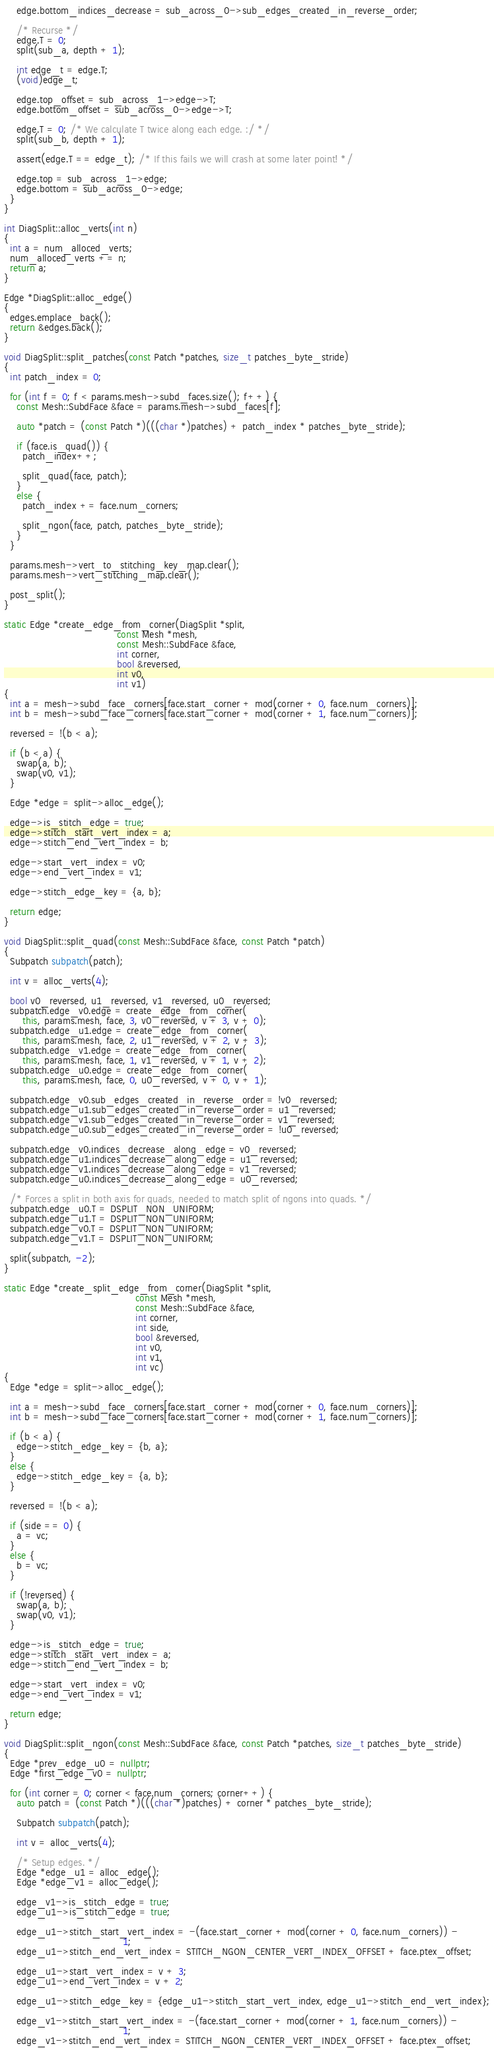Convert code to text. <code><loc_0><loc_0><loc_500><loc_500><_C++_>    edge.bottom_indices_decrease = sub_across_0->sub_edges_created_in_reverse_order;

    /* Recurse */
    edge.T = 0;
    split(sub_a, depth + 1);

    int edge_t = edge.T;
    (void)edge_t;

    edge.top_offset = sub_across_1->edge->T;
    edge.bottom_offset = sub_across_0->edge->T;

    edge.T = 0; /* We calculate T twice along each edge. :/ */
    split(sub_b, depth + 1);

    assert(edge.T == edge_t); /* If this fails we will crash at some later point! */

    edge.top = sub_across_1->edge;
    edge.bottom = sub_across_0->edge;
  }
}

int DiagSplit::alloc_verts(int n)
{
  int a = num_alloced_verts;
  num_alloced_verts += n;
  return a;
}

Edge *DiagSplit::alloc_edge()
{
  edges.emplace_back();
  return &edges.back();
}

void DiagSplit::split_patches(const Patch *patches, size_t patches_byte_stride)
{
  int patch_index = 0;

  for (int f = 0; f < params.mesh->subd_faces.size(); f++) {
    const Mesh::SubdFace &face = params.mesh->subd_faces[f];

    auto *patch = (const Patch *)(((char *)patches) + patch_index * patches_byte_stride);

    if (face.is_quad()) {
      patch_index++;

      split_quad(face, patch);
    }
    else {
      patch_index += face.num_corners;

      split_ngon(face, patch, patches_byte_stride);
    }
  }

  params.mesh->vert_to_stitching_key_map.clear();
  params.mesh->vert_stitching_map.clear();

  post_split();
}

static Edge *create_edge_from_corner(DiagSplit *split,
                                     const Mesh *mesh,
                                     const Mesh::SubdFace &face,
                                     int corner,
                                     bool &reversed,
                                     int v0,
                                     int v1)
{
  int a = mesh->subd_face_corners[face.start_corner + mod(corner + 0, face.num_corners)];
  int b = mesh->subd_face_corners[face.start_corner + mod(corner + 1, face.num_corners)];

  reversed = !(b < a);

  if (b < a) {
    swap(a, b);
    swap(v0, v1);
  }

  Edge *edge = split->alloc_edge();

  edge->is_stitch_edge = true;
  edge->stitch_start_vert_index = a;
  edge->stitch_end_vert_index = b;

  edge->start_vert_index = v0;
  edge->end_vert_index = v1;

  edge->stitch_edge_key = {a, b};

  return edge;
}

void DiagSplit::split_quad(const Mesh::SubdFace &face, const Patch *patch)
{
  Subpatch subpatch(patch);

  int v = alloc_verts(4);

  bool v0_reversed, u1_reversed, v1_reversed, u0_reversed;
  subpatch.edge_v0.edge = create_edge_from_corner(
      this, params.mesh, face, 3, v0_reversed, v + 3, v + 0);
  subpatch.edge_u1.edge = create_edge_from_corner(
      this, params.mesh, face, 2, u1_reversed, v + 2, v + 3);
  subpatch.edge_v1.edge = create_edge_from_corner(
      this, params.mesh, face, 1, v1_reversed, v + 1, v + 2);
  subpatch.edge_u0.edge = create_edge_from_corner(
      this, params.mesh, face, 0, u0_reversed, v + 0, v + 1);

  subpatch.edge_v0.sub_edges_created_in_reverse_order = !v0_reversed;
  subpatch.edge_u1.sub_edges_created_in_reverse_order = u1_reversed;
  subpatch.edge_v1.sub_edges_created_in_reverse_order = v1_reversed;
  subpatch.edge_u0.sub_edges_created_in_reverse_order = !u0_reversed;

  subpatch.edge_v0.indices_decrease_along_edge = v0_reversed;
  subpatch.edge_u1.indices_decrease_along_edge = u1_reversed;
  subpatch.edge_v1.indices_decrease_along_edge = v1_reversed;
  subpatch.edge_u0.indices_decrease_along_edge = u0_reversed;

  /* Forces a split in both axis for quads, needed to match split of ngons into quads. */
  subpatch.edge_u0.T = DSPLIT_NON_UNIFORM;
  subpatch.edge_u1.T = DSPLIT_NON_UNIFORM;
  subpatch.edge_v0.T = DSPLIT_NON_UNIFORM;
  subpatch.edge_v1.T = DSPLIT_NON_UNIFORM;

  split(subpatch, -2);
}

static Edge *create_split_edge_from_corner(DiagSplit *split,
                                           const Mesh *mesh,
                                           const Mesh::SubdFace &face,
                                           int corner,
                                           int side,
                                           bool &reversed,
                                           int v0,
                                           int v1,
                                           int vc)
{
  Edge *edge = split->alloc_edge();

  int a = mesh->subd_face_corners[face.start_corner + mod(corner + 0, face.num_corners)];
  int b = mesh->subd_face_corners[face.start_corner + mod(corner + 1, face.num_corners)];

  if (b < a) {
    edge->stitch_edge_key = {b, a};
  }
  else {
    edge->stitch_edge_key = {a, b};
  }

  reversed = !(b < a);

  if (side == 0) {
    a = vc;
  }
  else {
    b = vc;
  }

  if (!reversed) {
    swap(a, b);
    swap(v0, v1);
  }

  edge->is_stitch_edge = true;
  edge->stitch_start_vert_index = a;
  edge->stitch_end_vert_index = b;

  edge->start_vert_index = v0;
  edge->end_vert_index = v1;

  return edge;
}

void DiagSplit::split_ngon(const Mesh::SubdFace &face, const Patch *patches, size_t patches_byte_stride)
{
  Edge *prev_edge_u0 = nullptr;
  Edge *first_edge_v0 = nullptr;

  for (int corner = 0; corner < face.num_corners; corner++) {
    auto patch = (const Patch *)(((char *)patches) + corner * patches_byte_stride);

    Subpatch subpatch(patch);

    int v = alloc_verts(4);

    /* Setup edges. */
    Edge *edge_u1 = alloc_edge();
    Edge *edge_v1 = alloc_edge();

    edge_v1->is_stitch_edge = true;
    edge_u1->is_stitch_edge = true;

    edge_u1->stitch_start_vert_index = -(face.start_corner + mod(corner + 0, face.num_corners)) -
                                       1;
    edge_u1->stitch_end_vert_index = STITCH_NGON_CENTER_VERT_INDEX_OFFSET + face.ptex_offset;

    edge_u1->start_vert_index = v + 3;
    edge_u1->end_vert_index = v + 2;

    edge_u1->stitch_edge_key = {edge_u1->stitch_start_vert_index, edge_u1->stitch_end_vert_index};

    edge_v1->stitch_start_vert_index = -(face.start_corner + mod(corner + 1, face.num_corners)) -
                                       1;
    edge_v1->stitch_end_vert_index = STITCH_NGON_CENTER_VERT_INDEX_OFFSET + face.ptex_offset;
</code> 